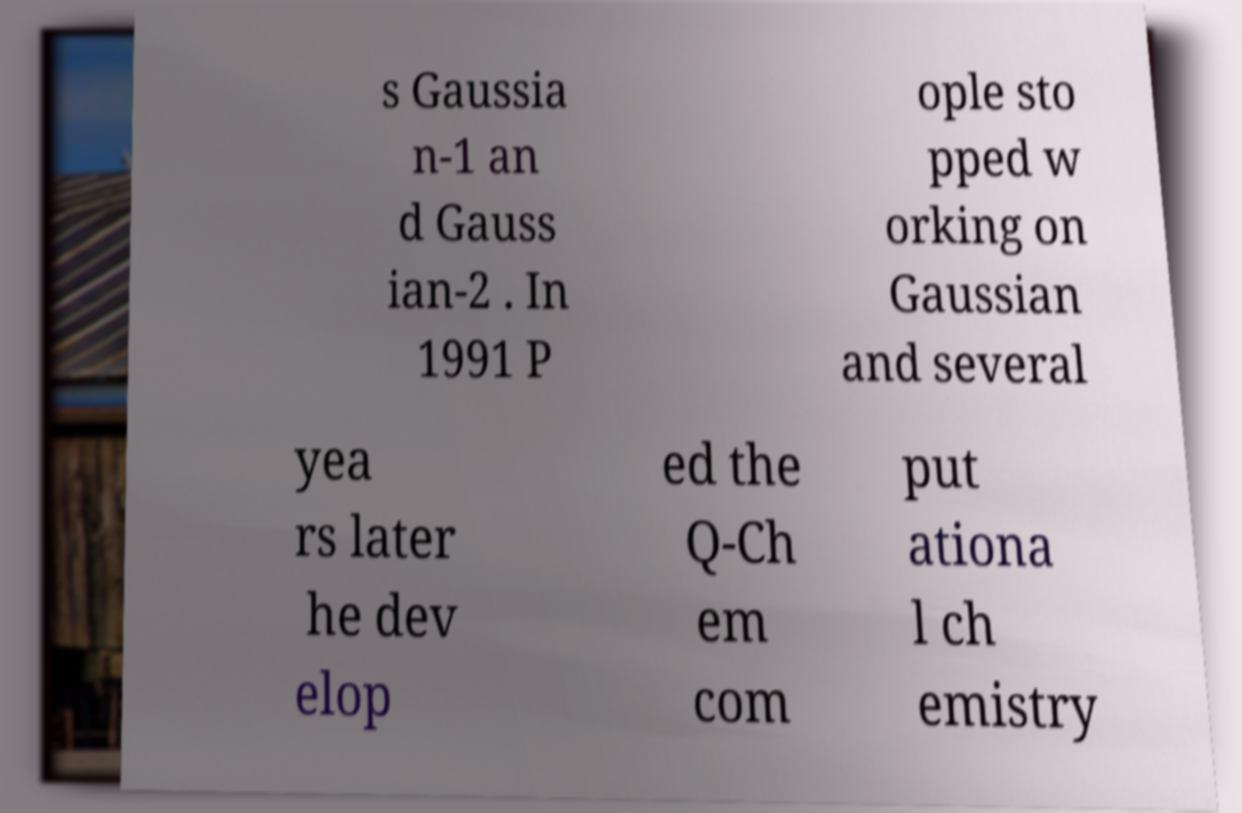Please identify and transcribe the text found in this image. s Gaussia n-1 an d Gauss ian-2 . In 1991 P ople sto pped w orking on Gaussian and several yea rs later he dev elop ed the Q-Ch em com put ationa l ch emistry 